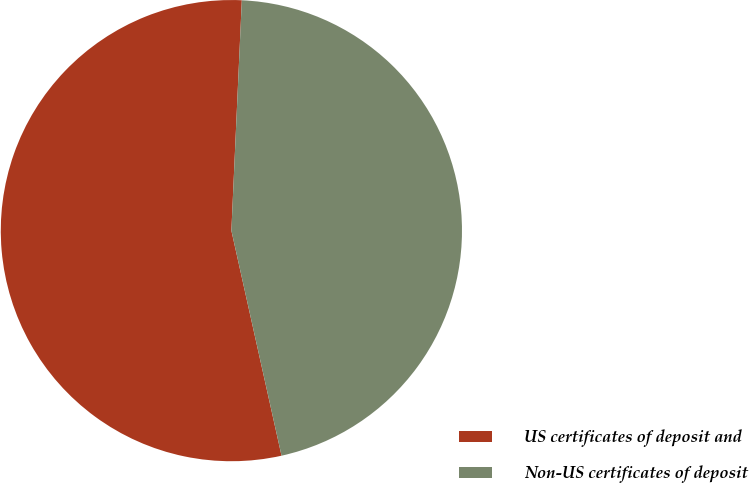<chart> <loc_0><loc_0><loc_500><loc_500><pie_chart><fcel>US certificates of deposit and<fcel>Non-US certificates of deposit<nl><fcel>54.21%<fcel>45.79%<nl></chart> 